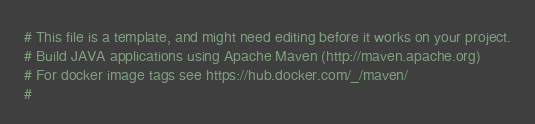Convert code to text. <code><loc_0><loc_0><loc_500><loc_500><_YAML_># This file is a template, and might need editing before it works on your project.
# Build JAVA applications using Apache Maven (http://maven.apache.org)
# For docker image tags see https://hub.docker.com/_/maven/
#</code> 